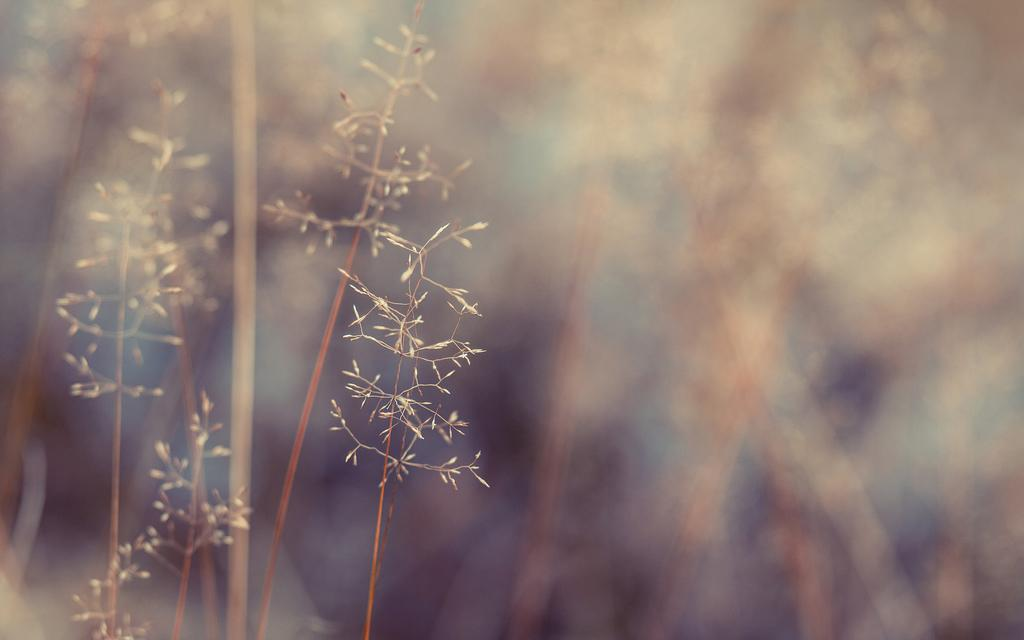What is present in the image? There are plants in the image. Can you describe the background of the image? The background of the image is blurred. What type of picture is inside the box in the image? There is no box or picture present in the image; it only features plants and a blurred background. 